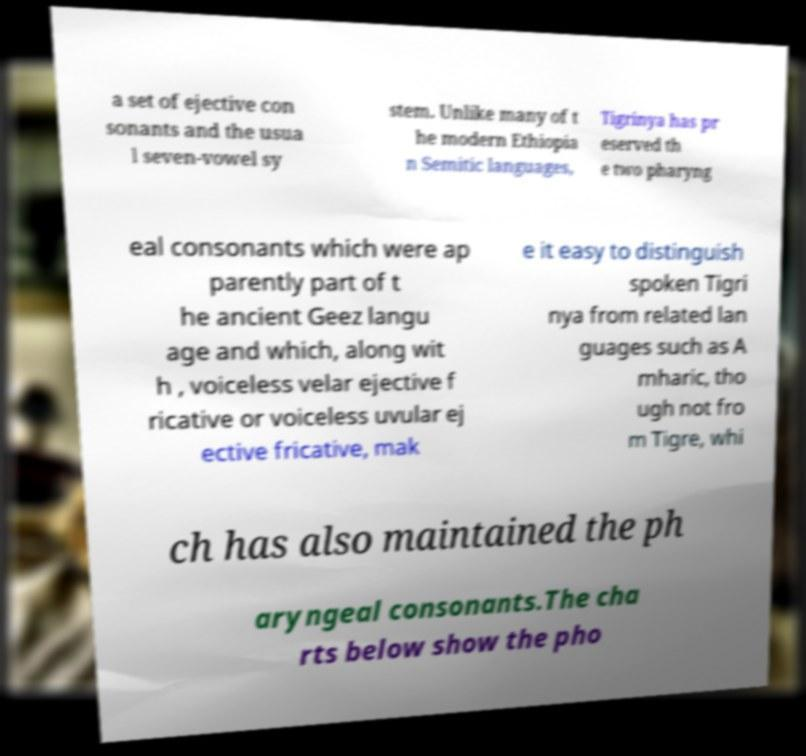What messages or text are displayed in this image? I need them in a readable, typed format. a set of ejective con sonants and the usua l seven-vowel sy stem. Unlike many of t he modern Ethiopia n Semitic languages, Tigrinya has pr eserved th e two pharyng eal consonants which were ap parently part of t he ancient Geez langu age and which, along wit h , voiceless velar ejective f ricative or voiceless uvular ej ective fricative, mak e it easy to distinguish spoken Tigri nya from related lan guages such as A mharic, tho ugh not fro m Tigre, whi ch has also maintained the ph aryngeal consonants.The cha rts below show the pho 